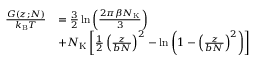Convert formula to latex. <formula><loc_0><loc_0><loc_500><loc_500>\begin{array} { r l } { \frac { G ( z ; N ) } { k _ { B } T } } & { = \frac { 3 } { 2 } \ln \left ( \frac { 2 \pi \beta N _ { K } } { 3 } \right ) } \\ & { + N _ { K } \left [ \frac { 1 } { 2 } \left ( \frac { z } { b N } \right ) ^ { 2 } - \ln \left ( 1 - \left ( \frac { z } { b N } \right ) ^ { 2 } \right ) \right ] } \end{array}</formula> 